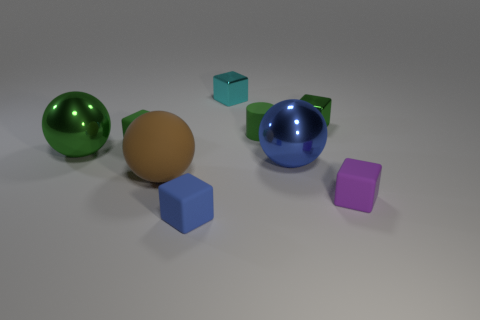Subtract all large blue metallic spheres. How many spheres are left? 2 Add 1 matte balls. How many objects exist? 10 Subtract 1 balls. How many balls are left? 2 Subtract all blue spheres. How many spheres are left? 2 Subtract 0 brown cubes. How many objects are left? 9 Subtract all cylinders. How many objects are left? 8 Subtract all green blocks. Subtract all cyan cylinders. How many blocks are left? 3 Subtract all yellow spheres. How many yellow cubes are left? 0 Subtract all large green metallic objects. Subtract all small blue rubber things. How many objects are left? 7 Add 4 small matte objects. How many small matte objects are left? 8 